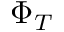Convert formula to latex. <formula><loc_0><loc_0><loc_500><loc_500>\Phi _ { T }</formula> 